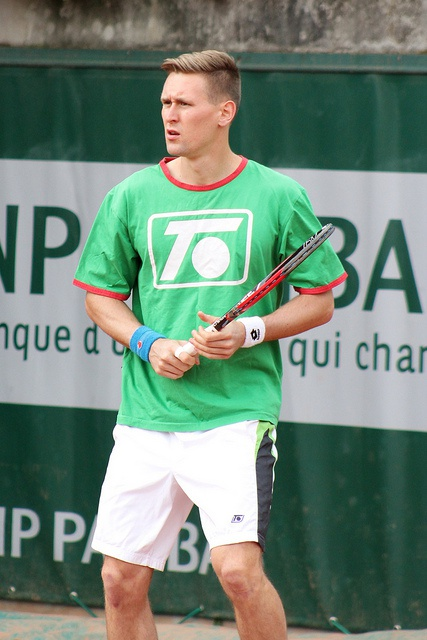Describe the objects in this image and their specific colors. I can see people in gray, white, lightgreen, tan, and green tones and tennis racket in gray, darkgray, white, and black tones in this image. 